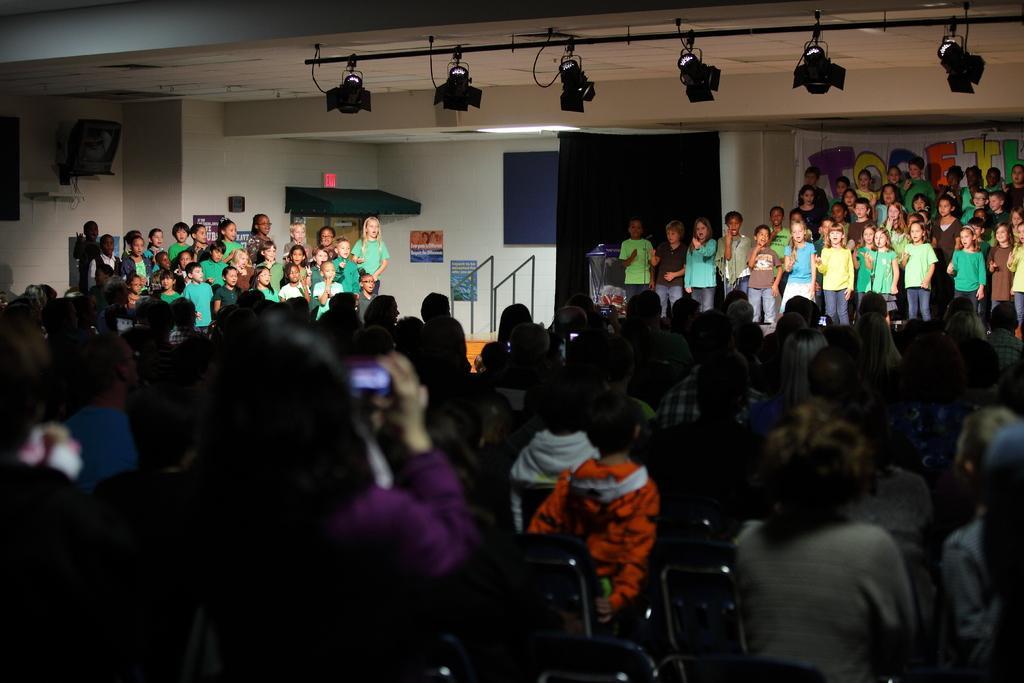Describe this image in one or two sentences. In this picture I can observe some people in the middle of the picture. In the background I can observe some children. There are boys and girls in this picture. Most of them are wearing green color T shirts. 